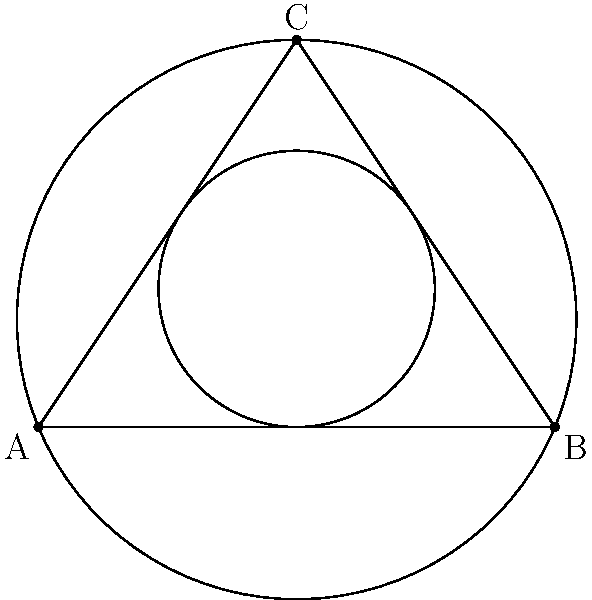A triangular beach umbrella has a circumscribed circle with radius $R$ and an inscribed circle with radius $r$. If the area of the triangular umbrella is 6 square feet, what is the ratio of $R$ to $r$? Let's approach this step-by-step:

1) For any triangle, the area $A$ can be expressed in terms of the semiperimeter $s$ and the radii $R$ and $r$:

   $$A = rs = \frac{abc}{4R}$$

   where $a$, $b$, and $c$ are the side lengths of the triangle.

2) From this, we can derive:

   $$R = \frac{abc}{4A}$$
   $$r = \frac{A}{s}$$

3) The ratio $R:r$ can be expressed as:

   $$\frac{R}{r} = \frac{abc}{4A} \cdot \frac{s}{A} = \frac{abc}{4A^2}s$$

4) We know that $s = \frac{a+b+c}{2}$, so:

   $$\frac{R}{r} = \frac{abc(a+b+c)}{8A^2}$$

5) Now, we need to express this in terms of $A$ only. There's a theorem that states:

   $$abc = 4AR$$

6) Substituting this into our ratio:

   $$\frac{R}{r} = \frac{4AR(a+b+c)}{8A^2} = \frac{R(a+b+c)}{2A}$$

7) There's another useful relation: $a+b+c = 4R$

8) Using this:

   $$\frac{R}{r} = \frac{R(4R)}{2A} = \frac{2R^2}{A}$$

9) We're given that $A = 6$ square feet, so:

   $$\frac{R}{r} = \frac{2R^2}{6} = \frac{R^2}{3}$$

Therefore, the ratio $R:r$ is $R^2:3$.
Answer: $R^2:3$ 